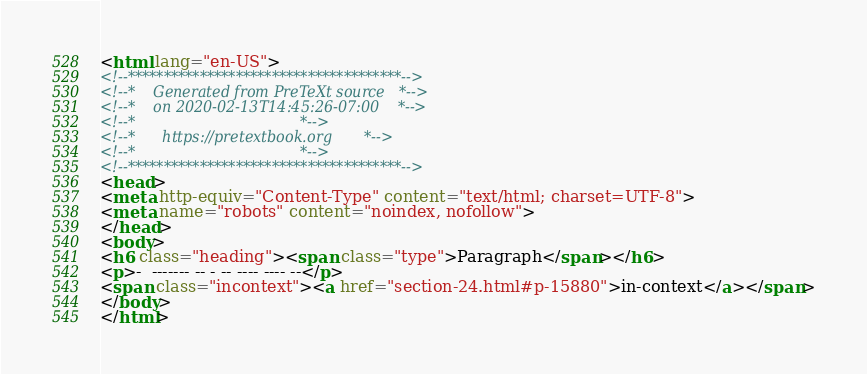<code> <loc_0><loc_0><loc_500><loc_500><_HTML_><html lang="en-US">
<!--**************************************-->
<!--*    Generated from PreTeXt source   *-->
<!--*    on 2020-02-13T14:45:26-07:00    *-->
<!--*                                    *-->
<!--*      https://pretextbook.org       *-->
<!--*                                    *-->
<!--**************************************-->
<head>
<meta http-equiv="Content-Type" content="text/html; charset=UTF-8">
<meta name="robots" content="noindex, nofollow">
</head>
<body>
<h6 class="heading"><span class="type">Paragraph</span></h6>
<p>-  ------- -- - -- ---- ---- --</p>
<span class="incontext"><a href="section-24.html#p-15880">in-context</a></span>
</body>
</html>
</code> 